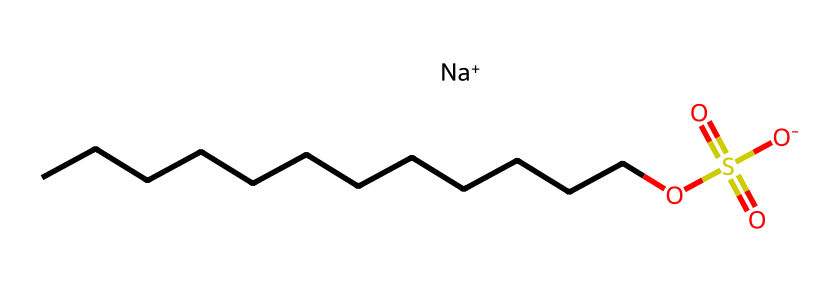how many carbon atoms are in sodium lauryl sulfate? The SMILES representation shows a chain of carbon atoms (CCCCCCCCCCCC), which indicates there are 12 carbon atoms in total.
Answer: 12 what type of ion is present in sodium lauryl sulfate? The chemical structure includes a sodium ion (Na+). The presence of [Na+] confirms that a positively charged ion is part of the compound.
Answer: sodium ion what functional group is indicated by the -OS(=O)(=O)[O-] part of the structure? The -OS(=O)(=O)[O-] part demonstrates the presence of a sulfate group (anion), which consists of sulfur and oxygen atoms. This is characteristic of surfactants like sodium lauryl sulfate.
Answer: sulfate group how many oxygen atoms are in sodium lauryl sulfate? In the sulfate group (OS(=O)(=O)[O-]), there are four oxygen atoms present. Counting ensures that they are all accounted for in the chemical representation.
Answer: 4 what is the main property of sodium lauryl sulfate that makes it a good detergent? The presence of both hydrophobic (carbon chain) and hydrophilic (sulfate group) parts allows it to effectively reduce surface tension and emulsify oils and fats in cleaning processes.
Answer: amphiphilic what is the total number of hydrogen atoms in sodium lauryl sulfate? Each carbon typically forms enough hydrogen atoms to complete its four bonds. With 12 carbons, there are 26 hydrogens (C12H25), but one hydrogen is replaced by the sulfate, so the total is 25.
Answer: 25 